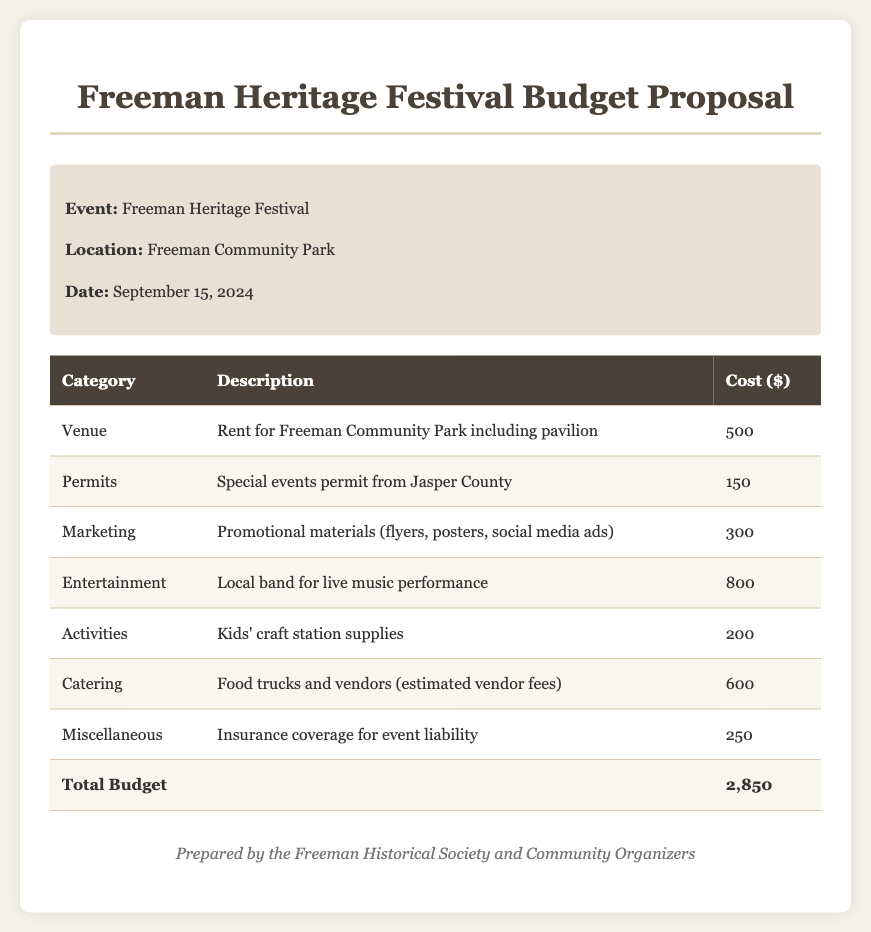What is the date of the Freeman Heritage Festival? The date of the festival is stated in the event details section of the document.
Answer: September 15, 2024 How much does the venue rental cost? The cost for the venue rental is listed in the budget table under the "Venue" category.
Answer: 500 What is the total budget for the festival? The total budget is presented as the sum of all costs in the table, located at the end of the budget section.
Answer: 2,850 What type of entertainment is planned for the festival? The document describes the entertainment category specifically mentioning a local band performance.
Answer: Local band How much are the estimated vendor fees for catering? The budget for catering is detailed under the respective category in the document.
Answer: 600 What permit is required for the festival? The permits category specifies the type of permit needed for the event in the document.
Answer: Special events permit How much is allocated for marketing? The amount allocated for marketing is specified in the budget under that category.
Answer: 300 What types of supplies are mentioned for activities? The activities category outlines the specific supplies planned for the festival.
Answer: Kids' craft station supplies Who prepared the budget proposal? The footer section of the document states who prepared the proposal.
Answer: Freeman Historical Society and Community Organizers 